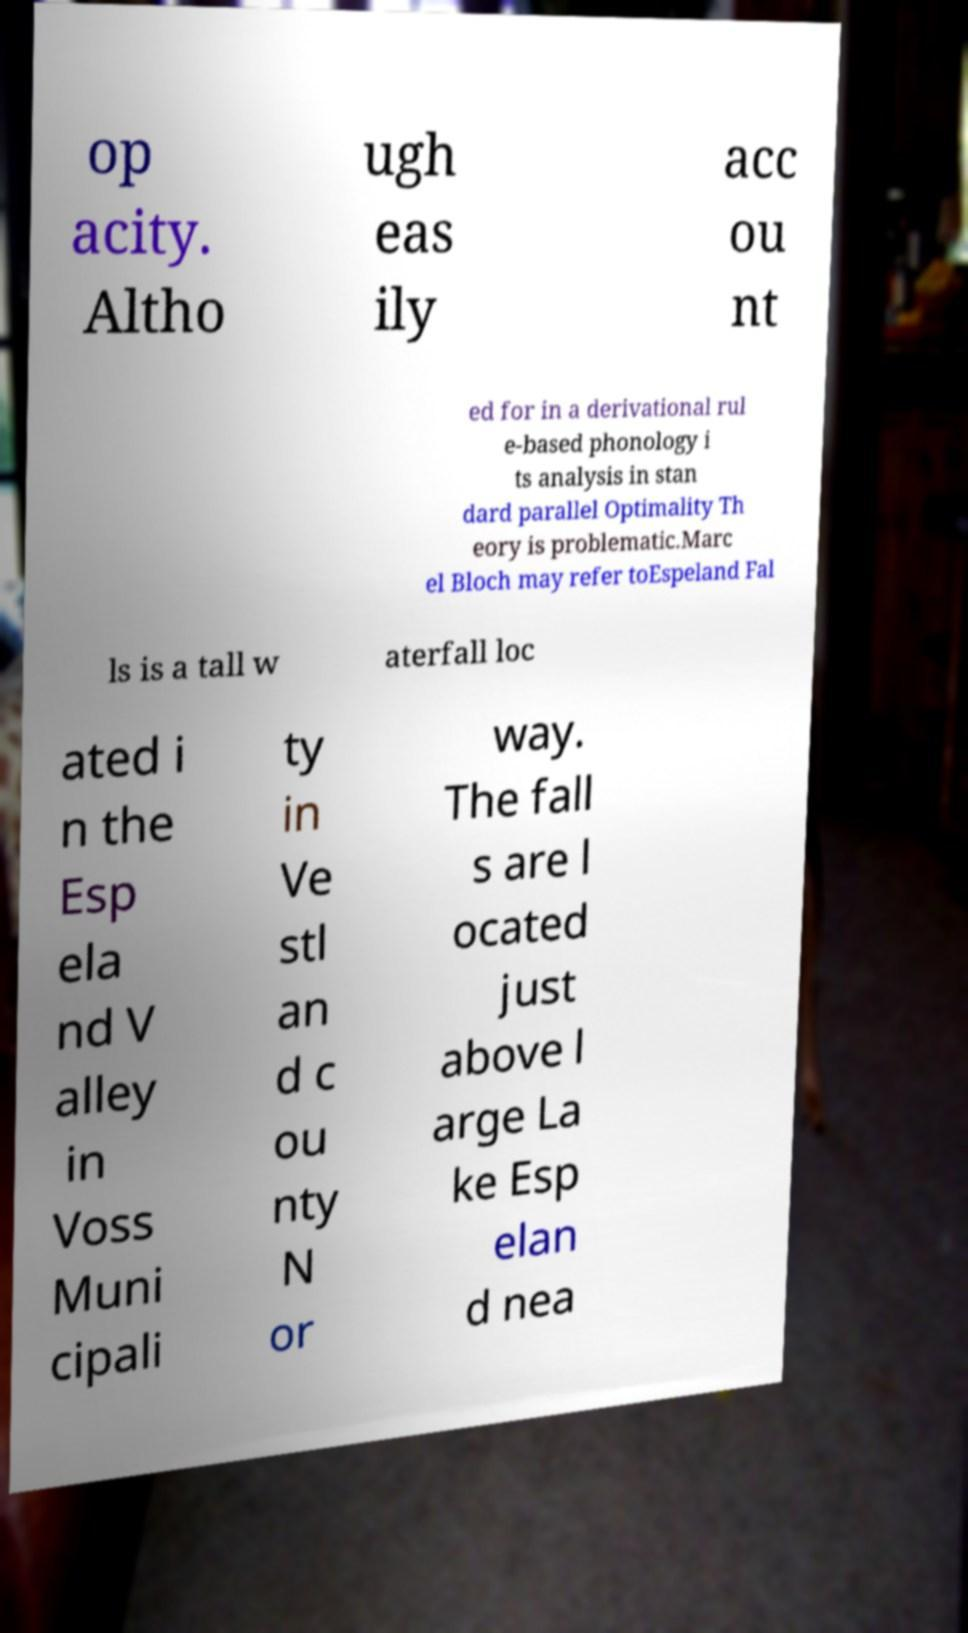What messages or text are displayed in this image? I need them in a readable, typed format. op acity. Altho ugh eas ily acc ou nt ed for in a derivational rul e-based phonology i ts analysis in stan dard parallel Optimality Th eory is problematic.Marc el Bloch may refer toEspeland Fal ls is a tall w aterfall loc ated i n the Esp ela nd V alley in Voss Muni cipali ty in Ve stl an d c ou nty N or way. The fall s are l ocated just above l arge La ke Esp elan d nea 